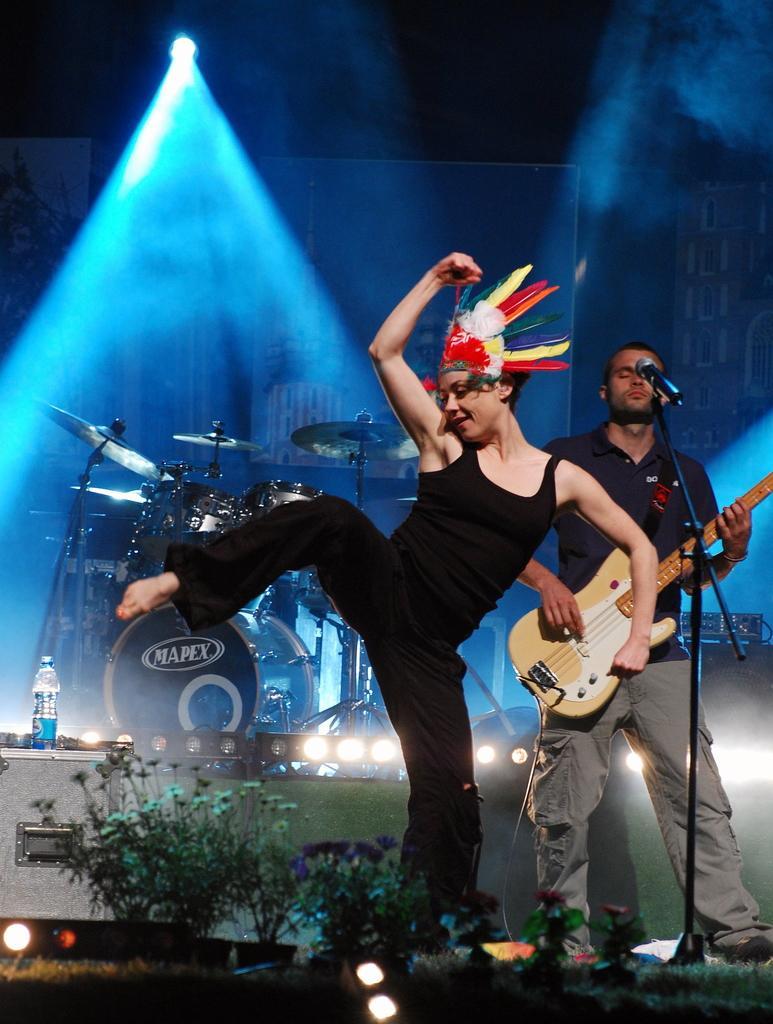Describe this image in one or two sentences. In this image I can see two persons a woman and a man. The man is playing guitar in front of a microphone and the woman is dancing on the stage. In the background I can see few musical instruments. 